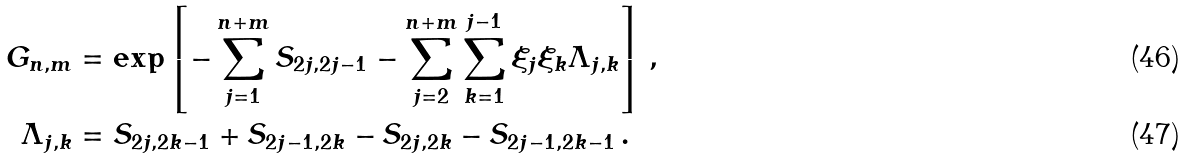<formula> <loc_0><loc_0><loc_500><loc_500>G _ { n , m } & = \exp \left [ - \sum _ { \substack { j = 1 } } ^ { n + m } S _ { 2 j , 2 j - 1 } - \sum _ { \substack { j = 2 } } ^ { n + m } \sum _ { \substack { k = 1 } } ^ { j - 1 } \xi _ { j } \xi _ { k } \Lambda _ { j , k } \right ] \, , \\ \Lambda _ { j , k } & = S _ { 2 j , 2 k - 1 } + S _ { 2 j - 1 , 2 k } - S _ { 2 j , 2 k } - S _ { 2 j - 1 , 2 k - 1 } \, .</formula> 